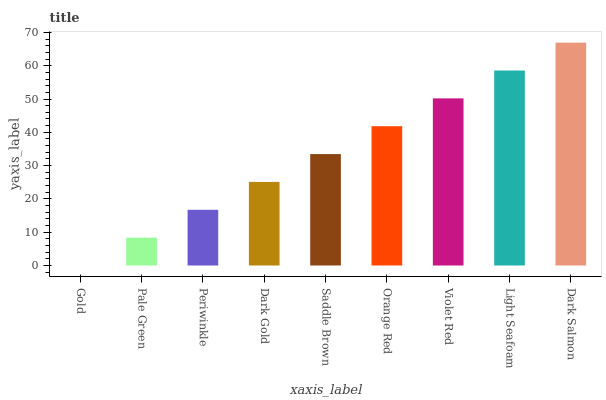Is Gold the minimum?
Answer yes or no. Yes. Is Dark Salmon the maximum?
Answer yes or no. Yes. Is Pale Green the minimum?
Answer yes or no. No. Is Pale Green the maximum?
Answer yes or no. No. Is Pale Green greater than Gold?
Answer yes or no. Yes. Is Gold less than Pale Green?
Answer yes or no. Yes. Is Gold greater than Pale Green?
Answer yes or no. No. Is Pale Green less than Gold?
Answer yes or no. No. Is Saddle Brown the high median?
Answer yes or no. Yes. Is Saddle Brown the low median?
Answer yes or no. Yes. Is Orange Red the high median?
Answer yes or no. No. Is Periwinkle the low median?
Answer yes or no. No. 